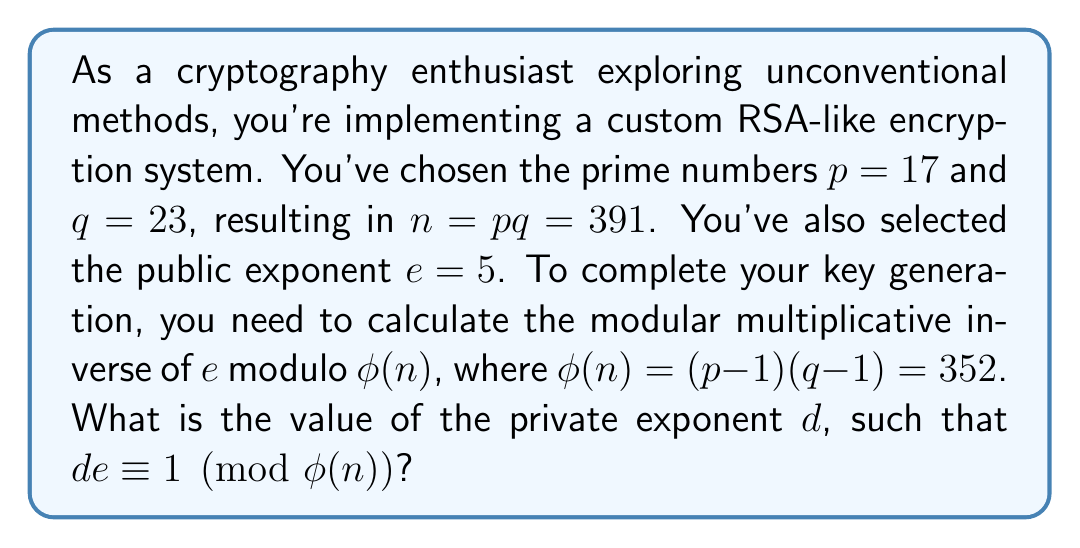Teach me how to tackle this problem. To find the modular multiplicative inverse, we need to solve the congruence:

$$ 5d \equiv 1 \pmod{352} $$

We can use the extended Euclidean algorithm to solve this. Let's apply the algorithm step by step:

1) First, set up the initial values:
   $352 = 70 \cdot 5 + 2$
   $5 = 2 \cdot 2 + 1$
   $2 = 2 \cdot 1 + 0$

2) Now, work backwards to express 1 as a linear combination of 352 and 5:
   $1 = 5 - 2 \cdot 2$
   $1 = 5 - 2 \cdot (352 - 70 \cdot 5)$
   $1 = 141 \cdot 5 - 2 \cdot 352$

3) Therefore, $141 \cdot 5 \equiv 1 \pmod{352}$

4) This means $d = 141$. However, we typically reduce $d$ modulo $\phi(n)$:
   $141 \equiv 141 \pmod{352}$

5) We can verify:
   $5 \cdot 141 = 705 \equiv 1 \pmod{352}$

Thus, the private exponent $d$ is 141.
Answer: $d = 141$ 